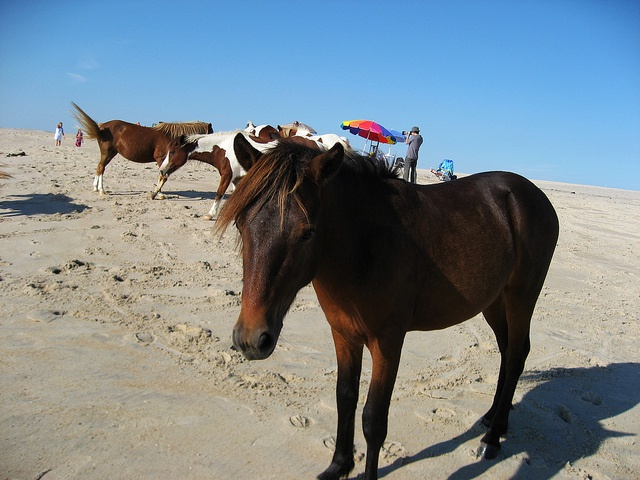Describe the objects in this image and their specific colors. I can see horse in blue, black, maroon, and gray tones, horse in blue, black, ivory, maroon, and darkgray tones, horse in blue, maroon, black, and gray tones, horse in blue, white, maroon, brown, and gray tones, and umbrella in blue, maroon, brown, navy, and salmon tones in this image. 